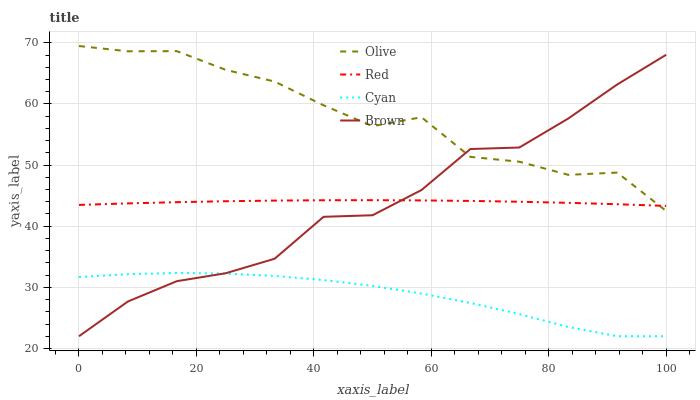Does Cyan have the minimum area under the curve?
Answer yes or no. Yes. Does Olive have the maximum area under the curve?
Answer yes or no. Yes. Does Red have the minimum area under the curve?
Answer yes or no. No. Does Red have the maximum area under the curve?
Answer yes or no. No. Is Red the smoothest?
Answer yes or no. Yes. Is Olive the roughest?
Answer yes or no. Yes. Is Cyan the smoothest?
Answer yes or no. No. Is Cyan the roughest?
Answer yes or no. No. Does Cyan have the lowest value?
Answer yes or no. Yes. Does Red have the lowest value?
Answer yes or no. No. Does Olive have the highest value?
Answer yes or no. Yes. Does Red have the highest value?
Answer yes or no. No. Is Cyan less than Olive?
Answer yes or no. Yes. Is Red greater than Cyan?
Answer yes or no. Yes. Does Red intersect Brown?
Answer yes or no. Yes. Is Red less than Brown?
Answer yes or no. No. Is Red greater than Brown?
Answer yes or no. No. Does Cyan intersect Olive?
Answer yes or no. No. 